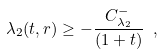Convert formula to latex. <formula><loc_0><loc_0><loc_500><loc_500>\lambda _ { 2 } ( t , r ) \geq - \frac { C ^ { - } _ { \lambda _ { 2 } } } { ( 1 + t ) } \ ,</formula> 